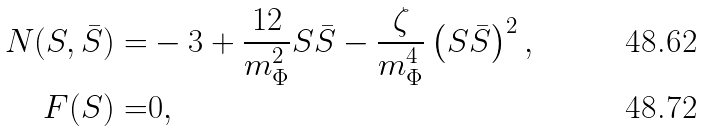Convert formula to latex. <formula><loc_0><loc_0><loc_500><loc_500>N ( S , \bar { S } ) = & - 3 + \frac { 1 2 } { m _ { \Phi } ^ { 2 } } S \bar { S } - \frac { \zeta } { m _ { \Phi } ^ { 4 } } \left ( S \bar { S } \right ) ^ { 2 } , \\ F ( S ) = & 0 ,</formula> 